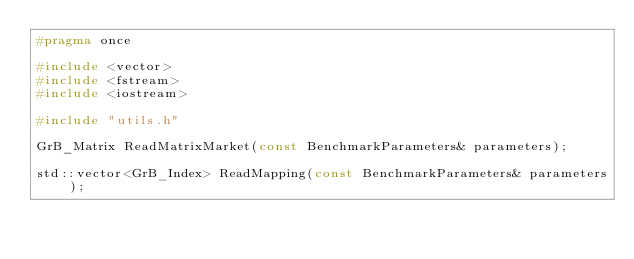<code> <loc_0><loc_0><loc_500><loc_500><_C_>#pragma once

#include <vector>
#include <fstream>
#include <iostream>

#include "utils.h"

GrB_Matrix ReadMatrixMarket(const BenchmarkParameters& parameters);

std::vector<GrB_Index> ReadMapping(const BenchmarkParameters& parameters);</code> 